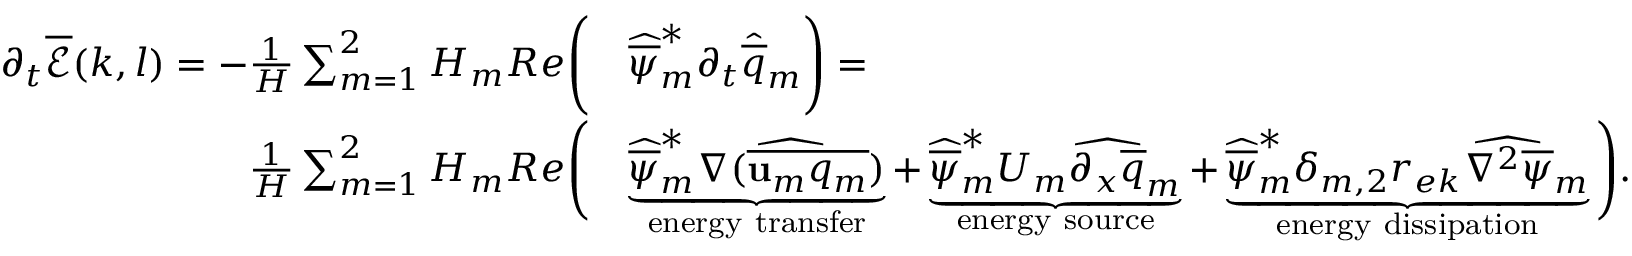Convert formula to latex. <formula><loc_0><loc_0><loc_500><loc_500>\begin{array} { r l } { \partial _ { t } \overline { { \mathcal { E } } } ( k , l ) = - \frac { 1 } { H } \sum _ { m = 1 } ^ { 2 } H _ { m } R e \left ( } & { \widehat { \overline { \psi } } _ { m } ^ { * } \partial _ { t } \widehat { \overline { q } } _ { m } \right ) = } \\ { \frac { 1 } { H } \sum _ { m = 1 } ^ { 2 } H _ { m } R e \left ( } & { \underbrace { \widehat { \overline { \psi } } _ { m } ^ { * } \widehat { \nabla ( \overline { { u _ { m } q _ { m } } } ) } } _ { e n e r g y t r a n s f e r } + \underbrace { \widehat { \overline { \psi } } _ { m } ^ { * } U _ { m } \widehat { \partial _ { x } \overline { q } } _ { m } } _ { e n e r g y s o u r c e } + \underbrace { \widehat { \overline { \psi } } _ { m } ^ { * } \delta _ { m , 2 } r _ { e k } \widehat { \nabla ^ { 2 } \overline { \psi } } _ { m } } _ { e n e r g y d i s s i p a t i o n } \right ) . } \end{array}</formula> 